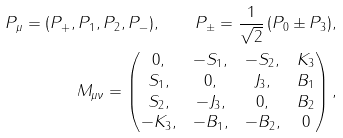Convert formula to latex. <formula><loc_0><loc_0><loc_500><loc_500>P _ { \mu } = ( P _ { + } , P _ { 1 } , P _ { 2 } , P _ { - } ) , \quad P _ { \pm } = \frac { 1 } { \sqrt { 2 } } \, ( P _ { 0 } \pm P _ { 3 } ) , \\ M _ { \mu \nu } = \begin{pmatrix} 0 , & - S _ { 1 } , & - S _ { 2 } , & K _ { 3 } \\ S _ { 1 } , & 0 , & J _ { 3 } , & B _ { 1 } \\ S _ { 2 } , & - J _ { 3 } , & 0 , & B _ { 2 } \\ - K _ { 3 } , & - B _ { 1 } , & - B _ { 2 } , & 0 \end{pmatrix} ,</formula> 